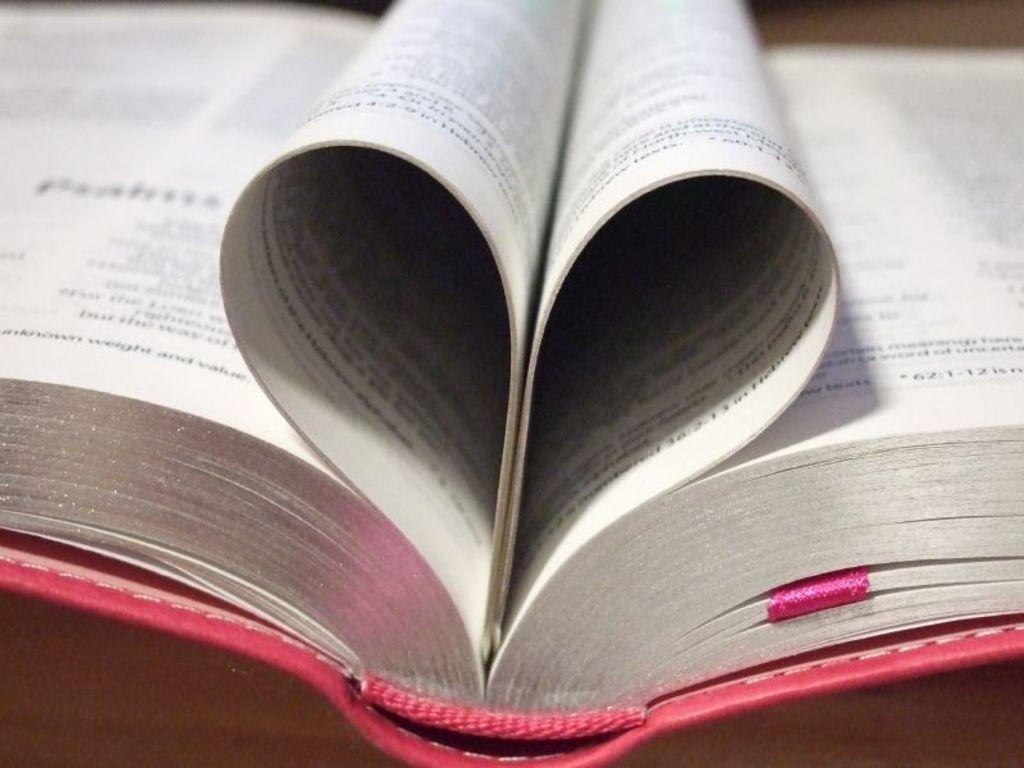<image>
Present a compact description of the photo's key features. a book making a heart shape out of two pages with the number 62 visible on the right page 